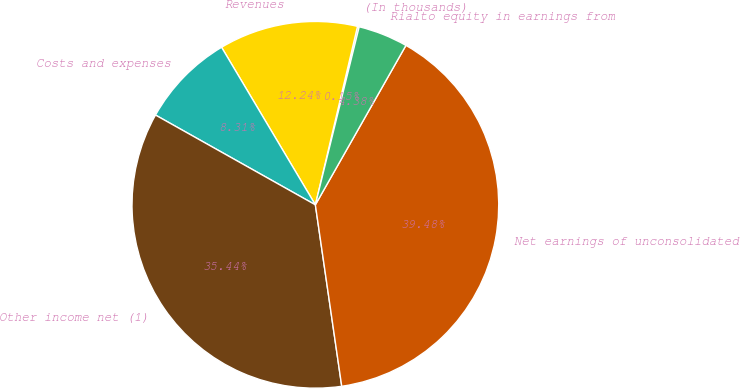<chart> <loc_0><loc_0><loc_500><loc_500><pie_chart><fcel>(In thousands)<fcel>Revenues<fcel>Costs and expenses<fcel>Other income net (1)<fcel>Net earnings of unconsolidated<fcel>Rialto equity in earnings from<nl><fcel>0.15%<fcel>12.24%<fcel>8.31%<fcel>35.44%<fcel>39.48%<fcel>4.38%<nl></chart> 